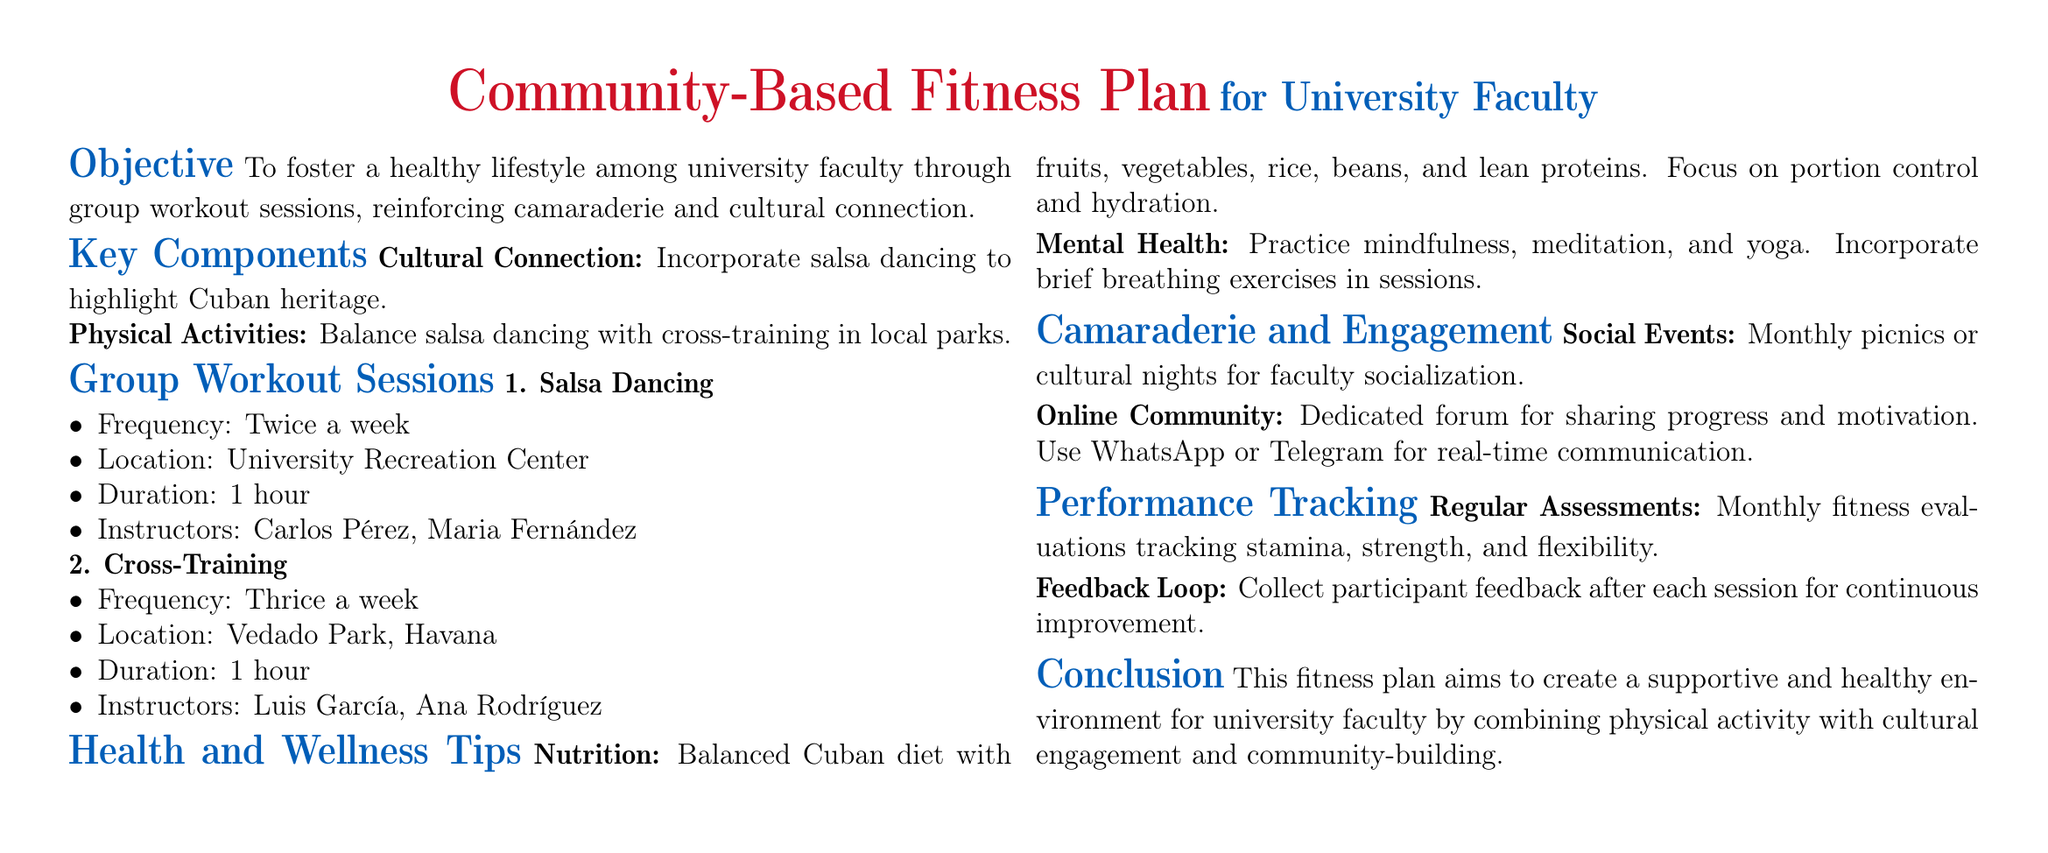What is the frequency of salsa dancing sessions? The salsa dancing sessions occur twice a week.
Answer: Twice a week Where is the cross-training session held? The cross-training sessions take place at Vedado Park, Havana.
Answer: Vedado Park, Havana Who are the instructors for salsa dancing? The document lists Carlos Pérez and Maria Fernández as salsa dancing instructors.
Answer: Carlos Pérez, Maria Fernández How many times a week are cross-training sessions scheduled? Cross-training sessions are scheduled three times a week.
Answer: Thrice a week What type of diet is recommended? The recommended diet emphasizes a balanced Cuban diet with specific foods.
Answer: Balanced Cuban diet What is the duration of each workout session? Each workout session lasts for one hour.
Answer: 1 hour What is the purpose of monthly picnics? The monthly picnics serve as a socialization opportunity for faculty.
Answer: Socialization How is participant feedback collected? Feedback is collected after each session for continuous improvement.
Answer: After each session What is the aim of the fitness plan? The fitness plan aims at creating a supportive and healthy environment for faculty.
Answer: Supportive and healthy environment 